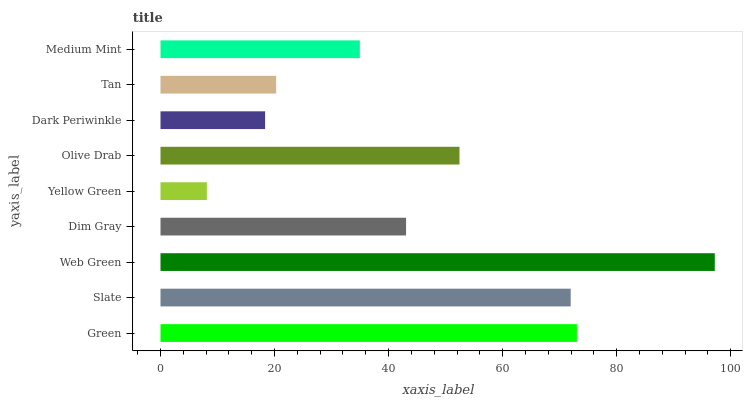Is Yellow Green the minimum?
Answer yes or no. Yes. Is Web Green the maximum?
Answer yes or no. Yes. Is Slate the minimum?
Answer yes or no. No. Is Slate the maximum?
Answer yes or no. No. Is Green greater than Slate?
Answer yes or no. Yes. Is Slate less than Green?
Answer yes or no. Yes. Is Slate greater than Green?
Answer yes or no. No. Is Green less than Slate?
Answer yes or no. No. Is Dim Gray the high median?
Answer yes or no. Yes. Is Dim Gray the low median?
Answer yes or no. Yes. Is Web Green the high median?
Answer yes or no. No. Is Web Green the low median?
Answer yes or no. No. 